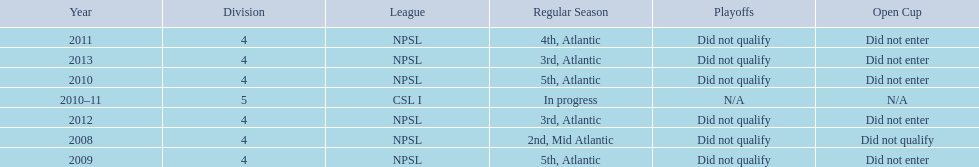What are all of the leagues? NPSL, NPSL, NPSL, CSL I, NPSL, NPSL, NPSL. Which league was played in the least? CSL I. 